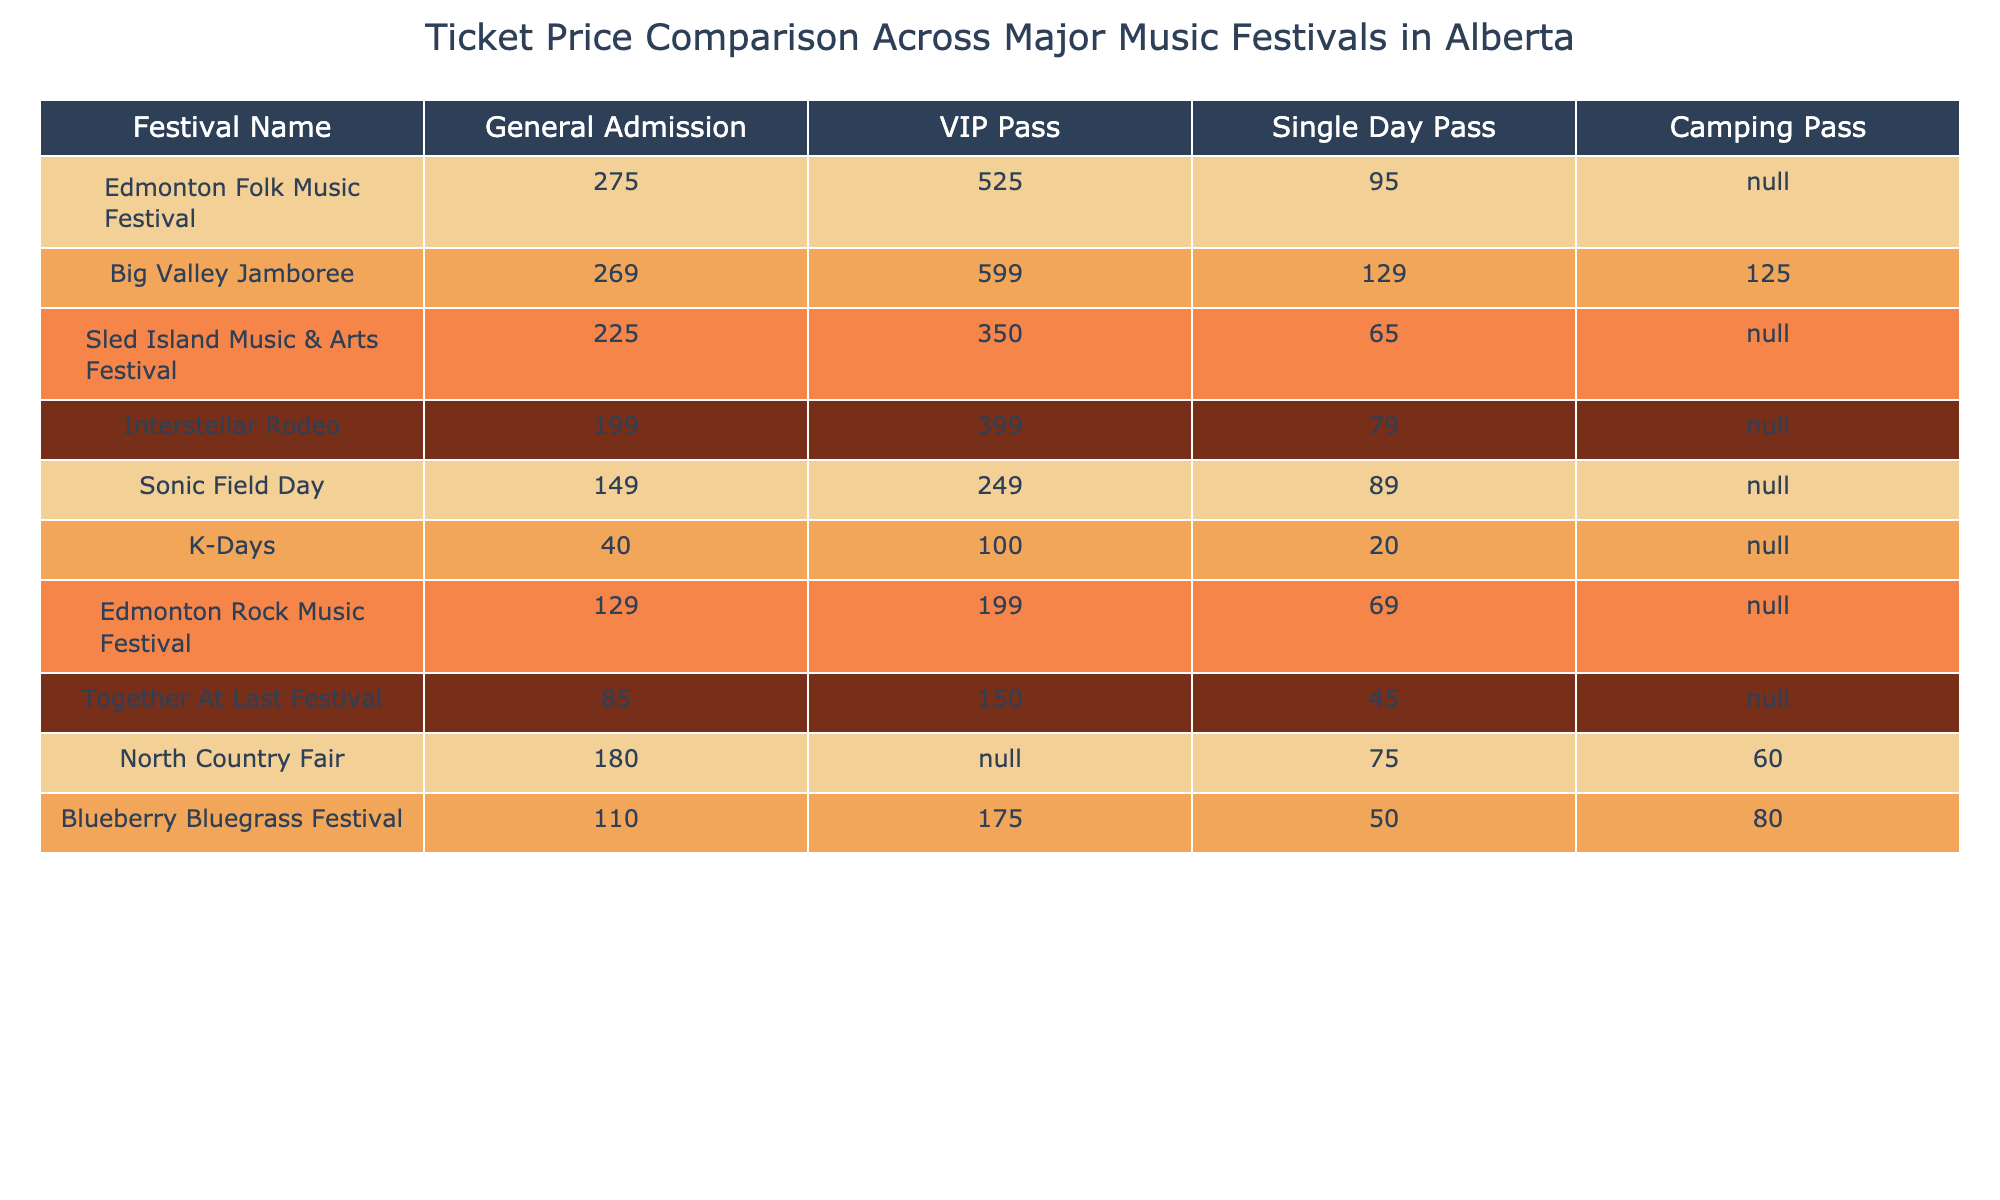What is the ticket price for the VIP Pass at the Edmonton Folk Music Festival? The table shows that the VIP Pass for the Edmonton Folk Music Festival is priced at 525.
Answer: 525 Which festival has the lowest General Admission price? By scanning the General Admission column, Sonic Field Day is the festival with the lowest price at 149.
Answer: 149 What is the difference in price between the VIP Pass of Big Valley Jamboree and the VIP Pass of K-Days? The VIP Pass for Big Valley Jamboree is 599, while for K-Days it is 100. The difference is calculated as 599 - 100 = 499.
Answer: 499 Is there a Camping Pass available for the Sled Island Music & Arts Festival? Looking at the Camping Pass column for Sled Island Music & Arts Festival, it is marked as N/A, indicating there is no Camping Pass available.
Answer: No What is the average price of a Single Day Pass across all festivals listed? The prices for Single Day Passes are: 95, 129, 65, 79, 89, 20, 69, 45, 75, 50. Adding them up gives 95 + 129 + 65 + 79 + 89 + 20 + 69 + 45 + 75 + 50 =  815. Dividing by the number of festivals (10) gives an average of 81.5.
Answer: 81.5 Which festival has the highest price for General Admission? Checking the General Admission column, Big Valley Jamboree has the highest price at 269.
Answer: 269 If I want to attend the North Country Fair, how much will I spend on the Camping Pass? Looking at the Camping Pass column for North Country Fair, it shows a price of 60.
Answer: 60 What is the total cost for attending the Edmonton Folk Music Festival (General Admission plus VIP Pass)? The prices for Edmonton Folk Music Festival are 275 for General Admission and 525 for the VIP Pass. The total is 275 + 525 = 800.
Answer: 800 Is the Single Day Pass more expensive than the Camping Pass for the Big Valley Jamboree? The Single Day Pass for Big Valley Jamboree costs 129, while the Camping Pass costs 125. Since 129 > 125, the Single Day Pass is indeed more expensive.
Answer: Yes How does the price of a VIP Pass at the Interstellar Rodeo compare with the price of a General Admission ticket at the K-Days? The VIP Pass for Interstellar Rodeo costs 399, while the General Admission for K-Days is 40. The VIP Pass is significantly more expensive since 399 > 40.
Answer: More expensive Which festival has a General Admission price that is less than 150? Scanning the General Admission prices, Sonic Field Day (149) and K-Days (40) both have prices less than 150.
Answer: Sonic Field Day and K-Days 